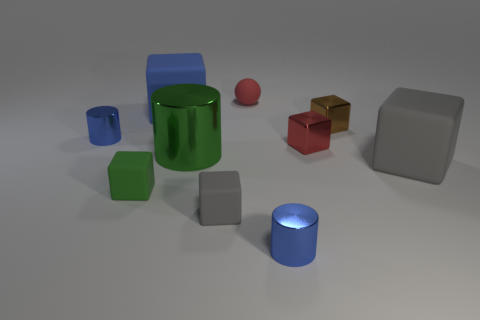Subtract all large matte blocks. How many blocks are left? 4 Subtract all cylinders. How many objects are left? 7 Subtract all blue cubes. How many cubes are left? 5 Subtract 4 blocks. How many blocks are left? 2 Subtract all purple cubes. Subtract all gray cylinders. How many cubes are left? 6 Subtract all yellow blocks. How many blue cylinders are left? 2 Subtract all rubber things. Subtract all large cyan blocks. How many objects are left? 5 Add 7 red objects. How many red objects are left? 9 Add 4 big metallic things. How many big metallic things exist? 5 Subtract 0 purple blocks. How many objects are left? 10 